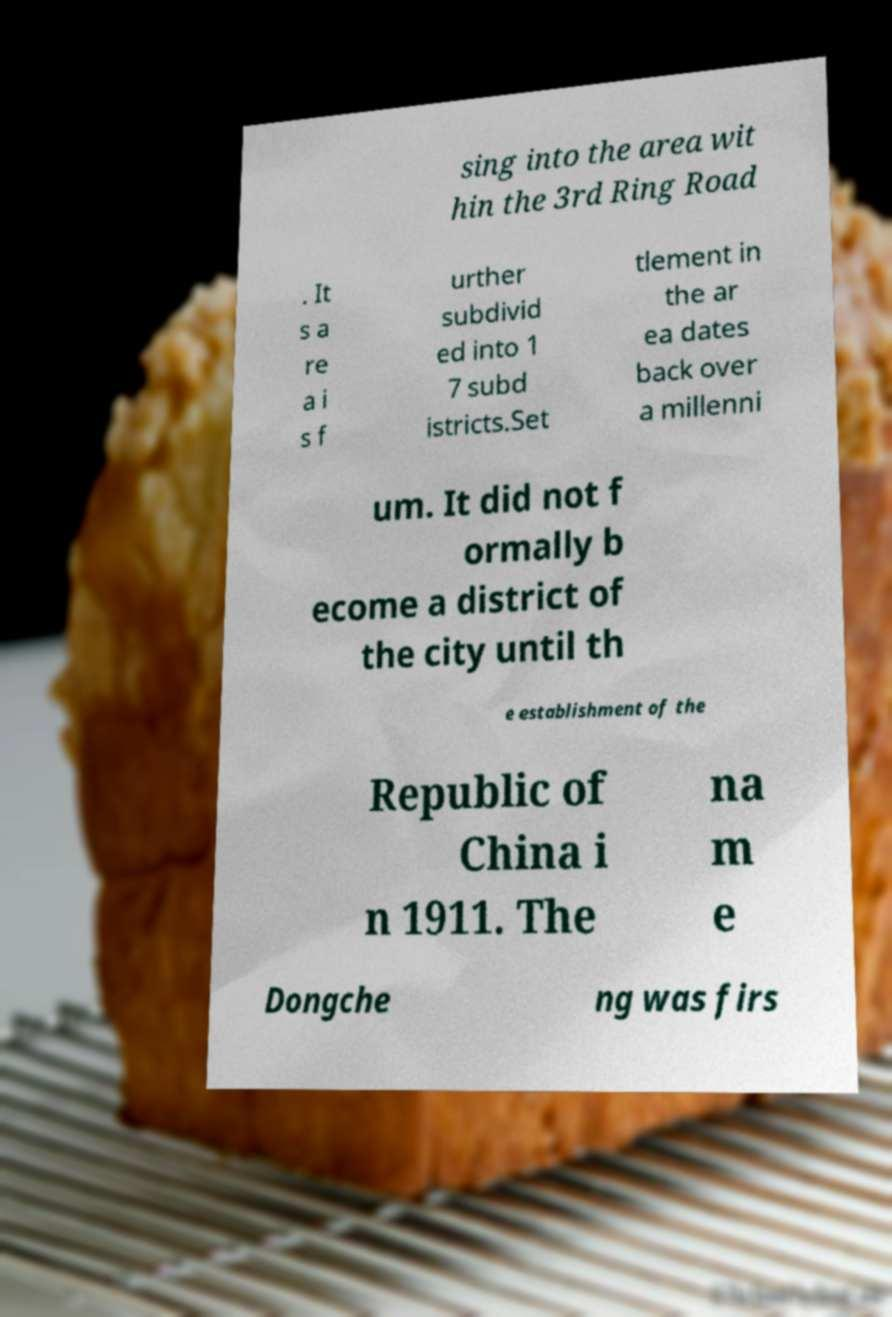There's text embedded in this image that I need extracted. Can you transcribe it verbatim? sing into the area wit hin the 3rd Ring Road . It s a re a i s f urther subdivid ed into 1 7 subd istricts.Set tlement in the ar ea dates back over a millenni um. It did not f ormally b ecome a district of the city until th e establishment of the Republic of China i n 1911. The na m e Dongche ng was firs 